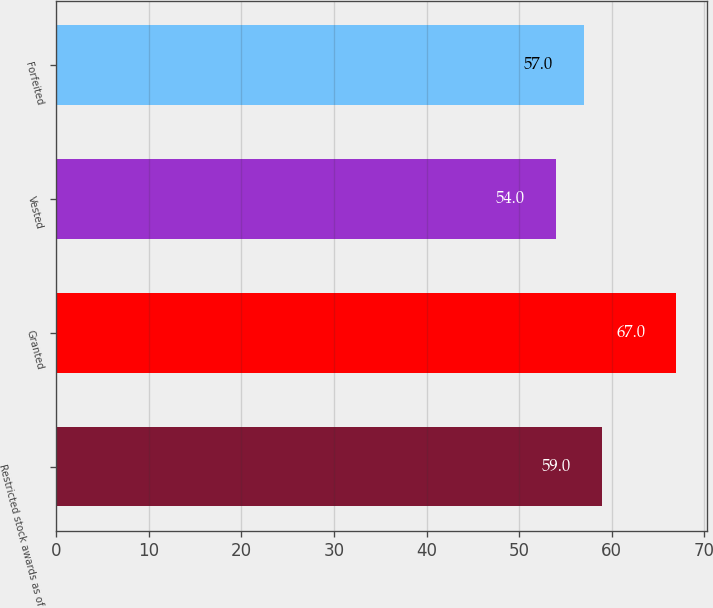Convert chart to OTSL. <chart><loc_0><loc_0><loc_500><loc_500><bar_chart><fcel>Restricted stock awards as of<fcel>Granted<fcel>Vested<fcel>Forfeited<nl><fcel>59<fcel>67<fcel>54<fcel>57<nl></chart> 